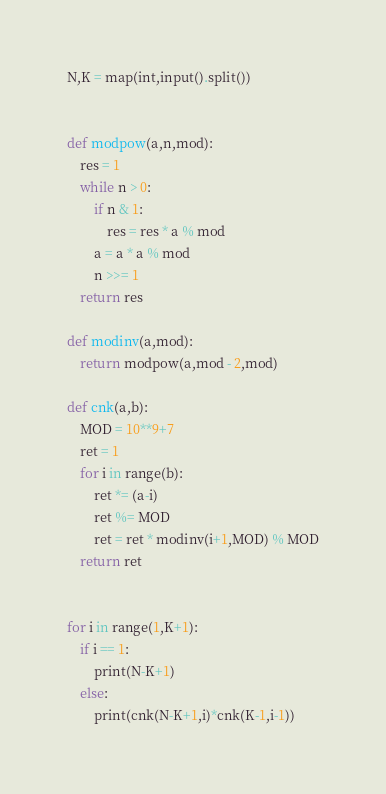Convert code to text. <code><loc_0><loc_0><loc_500><loc_500><_Python_>N,K = map(int,input().split())
 
 
def modpow(a,n,mod):
    res = 1
    while n > 0:
        if n & 1:
            res = res * a % mod
        a = a * a % mod
        n >>= 1
    return res
 
def modinv(a,mod):
    return modpow(a,mod - 2,mod)
 
def cnk(a,b):
    MOD = 10**9+7
    ret = 1
    for i in range(b):
        ret *= (a-i)
        ret %= MOD
        ret = ret * modinv(i+1,MOD) % MOD
    return ret
 
 
for i in range(1,K+1):
    if i == 1:
        print(N-K+1)
    else:
        print(cnk(N-K+1,i)*cnk(K-1,i-1))</code> 